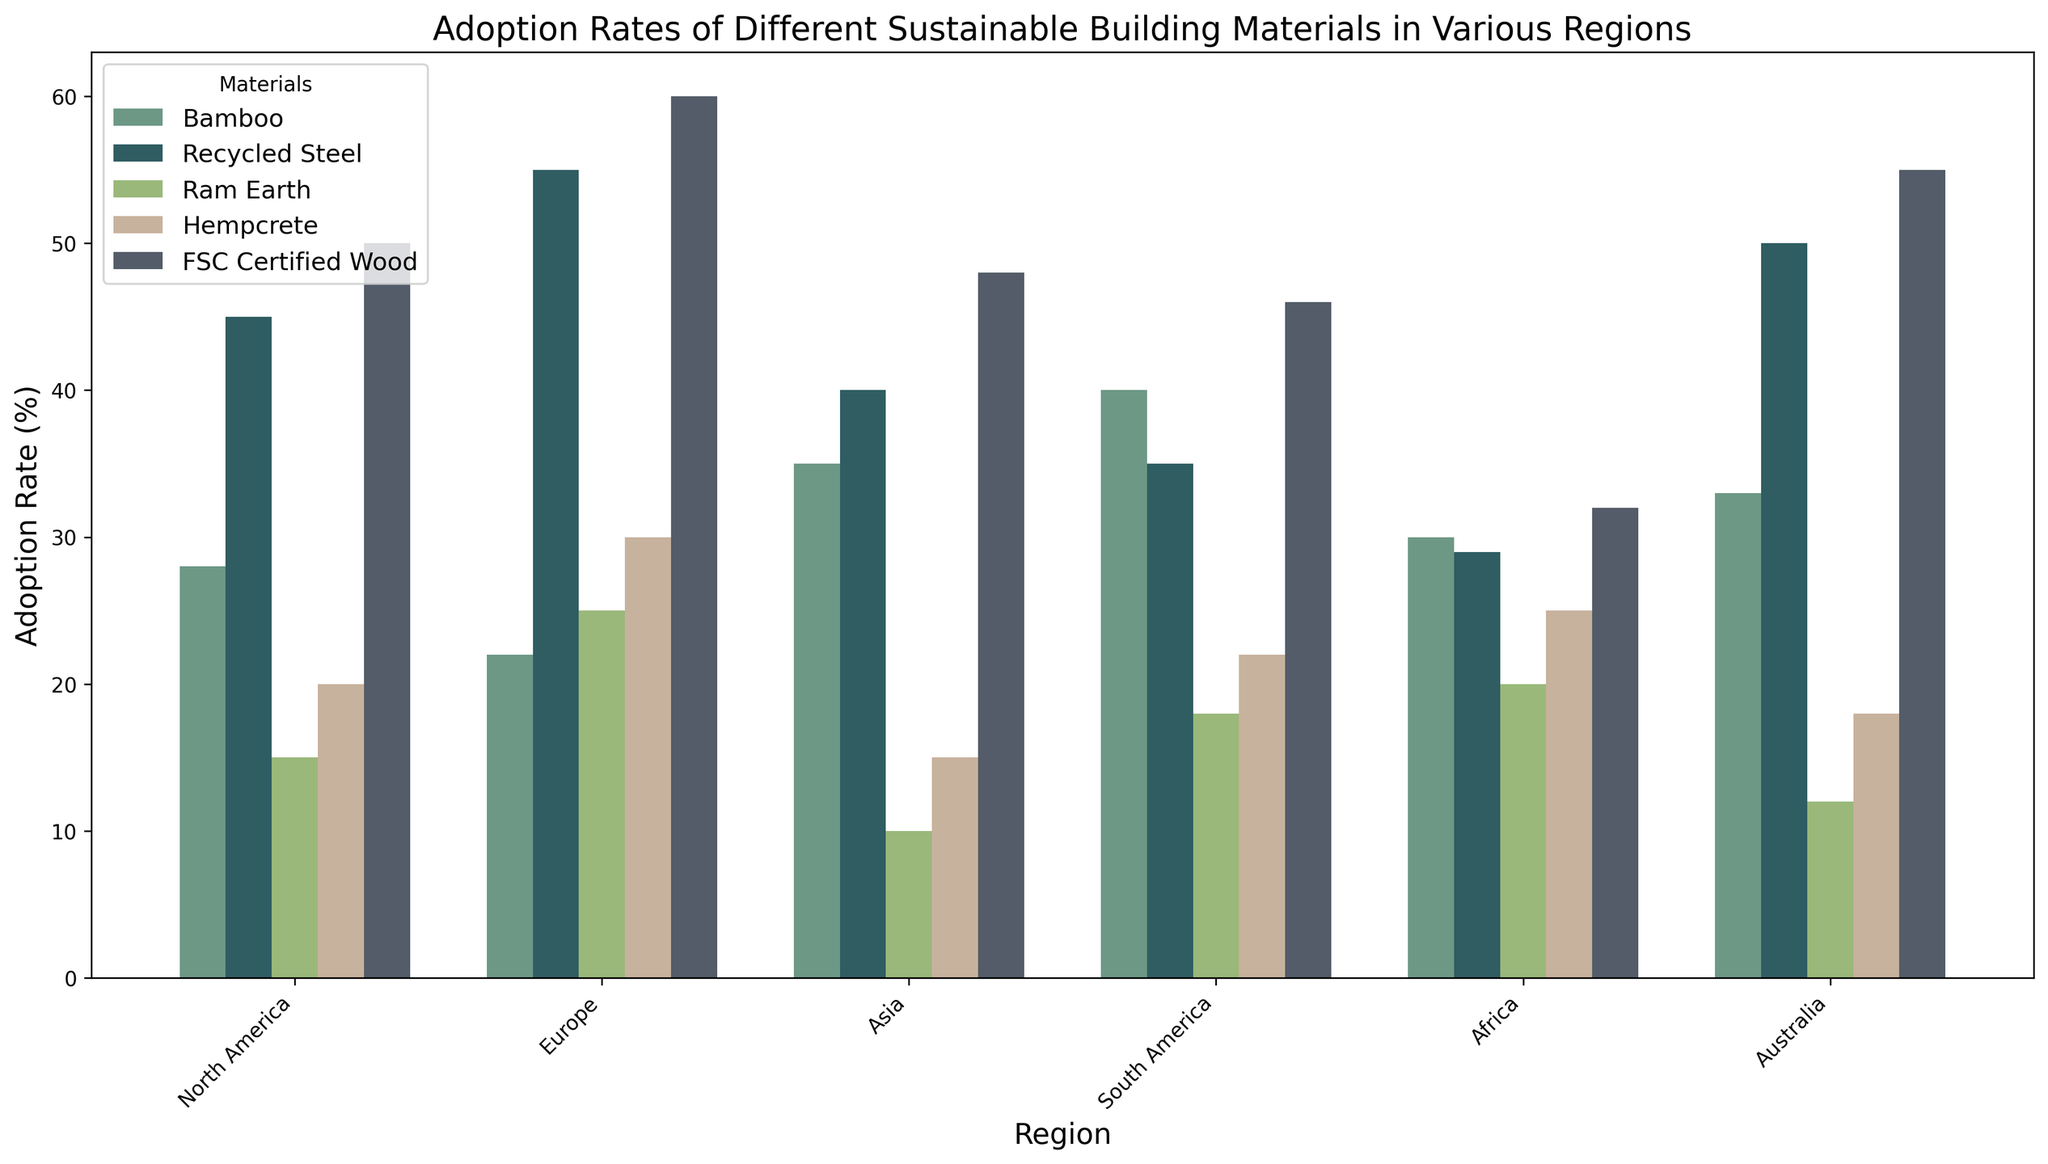Which region has the highest adoption rate for Recycled Steel? Identify the bar representing Recycled Steel for each region and compare their heights. Europe has the tallest bar for Recycled Steel, indicating the highest adoption rate.
Answer: Europe What is the average adoption rate of Bamboo across all regions? Sum the adoption rates for Bamboo in each region (28 + 22 + 35 + 40 + 30 + 33) and divide by the number of regions, which is 6. This calculation is (28 + 22 + 35 + 40 + 30 + 33) / 6 = 188 / 6.
Answer: 31.33 Which material shows the greatest variation in adoption rates across different regions? Observe the differences in bar heights for each material across regions. Bamboo and FSC Certified Wood have significant variation, but FSC Certified Wood has higher and lower extremes.
Answer: FSC Certified Wood Compare the adoption rates of Hempcrete in Europe and North America. Which region has a higher rate and by how much? Locate the bars representing Hempcrete for Europe and North America. Subtract the adoption rate in North America (20%) from that in Europe (30%).
Answer: Europe, by 10% What's the total adoption rate of sustainable materials in Africa? Sum the adoption rates for all materials in Africa (30 + 29 + 20 + 25 + 32). This calculation is 30 + 29 + 20 + 25 + 32.
Answer: 136 Which region has the lowest adoption rate for Ram Earth, and what is the value? Compare the bars for Ram Earth across all regions and identify the shortest bar, which corresponds to the lowest adoption rate. Asia has the smallest bar for Ram Earth at 10%.
Answer: Asia, 10% How much higher is the adoption rate of FSC Certified Wood in Europe compared to Africa? Identify the bars for FSC Certified Wood in Europe and Africa. Subtract the rate in Africa (32%) from that in Europe (60%).
Answer: 28% What is the median adoption rate of Recycled Steel across all regions? List the adoption rates for Recycled Steel (45, 55, 40, 35, 29, 50). Sort these values (29, 35, 40, 45, 50, 55). The median is the average of the middle two numbers, (40 + 45) / 2.
Answer: 42.5 Rank the adoption rates of Bamboo from highest to lowest across the regions. Compare and list the adoption rates for Bamboo in all regions: (40, 35, 33, 30, 28, 22). Sort these values in descending order: 40, 35, 33, 30, 28, 22.
Answer: South America, Asia, Australia, Africa, North America, Europe Which two materials have the closest adoption rates in North America? Compare the heights of the bars in North America. Hempcrete (20%) and Ram Earth (15%) are the closest in heights.
Answer: Hempcrete and Ram Earth 